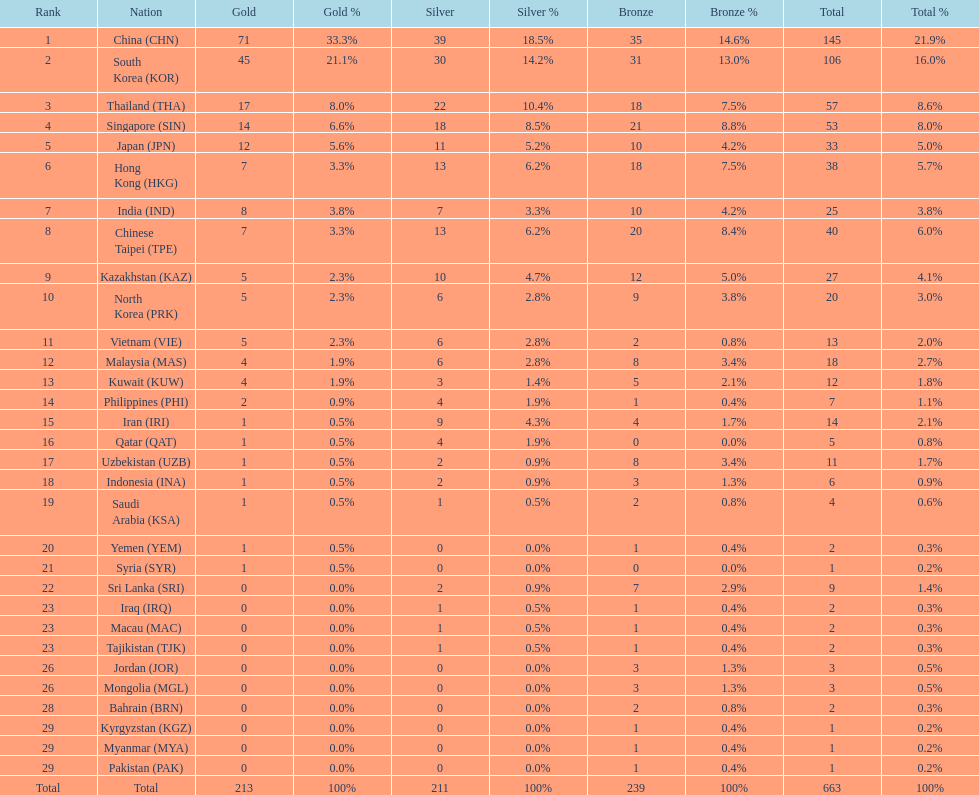How many more gold medals must qatar win before they can earn 12 gold medals? 11. 